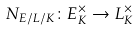<formula> <loc_0><loc_0><loc_500><loc_500>N _ { E / L / K } \colon E _ { K } ^ { \times } \to L _ { K } ^ { \times }</formula> 